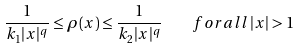<formula> <loc_0><loc_0><loc_500><loc_500>\frac { 1 } { k _ { 1 } | x | ^ { q } } \leq \rho ( x ) \leq \frac { 1 } { k _ { 2 } | x | ^ { q } } \quad f o r a l l \, | x | > 1</formula> 